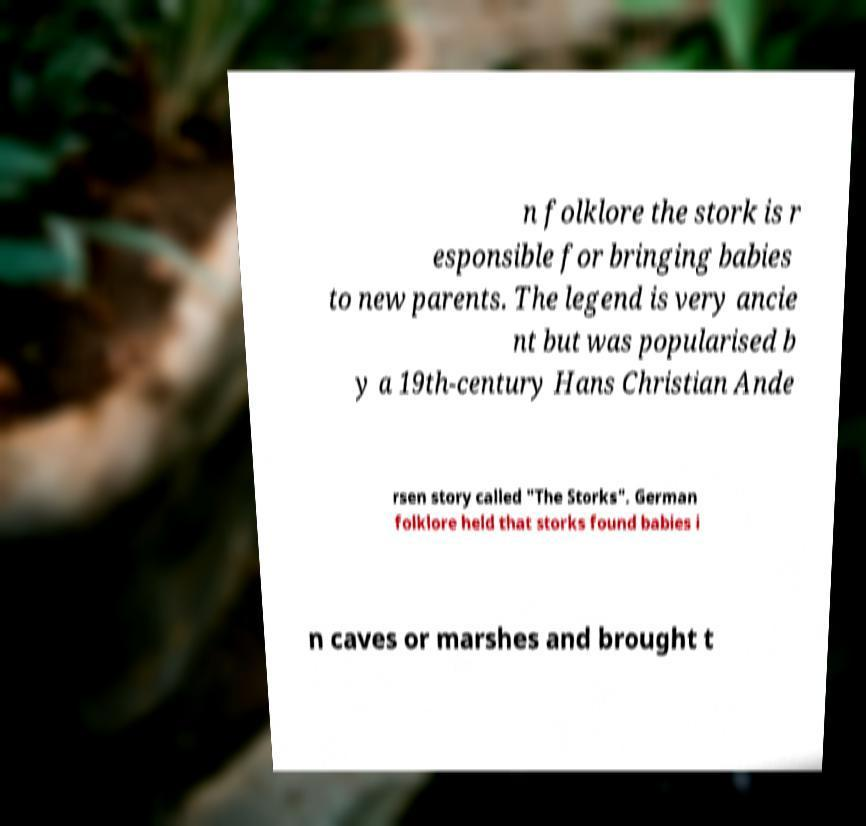Could you assist in decoding the text presented in this image and type it out clearly? n folklore the stork is r esponsible for bringing babies to new parents. The legend is very ancie nt but was popularised b y a 19th-century Hans Christian Ande rsen story called "The Storks". German folklore held that storks found babies i n caves or marshes and brought t 